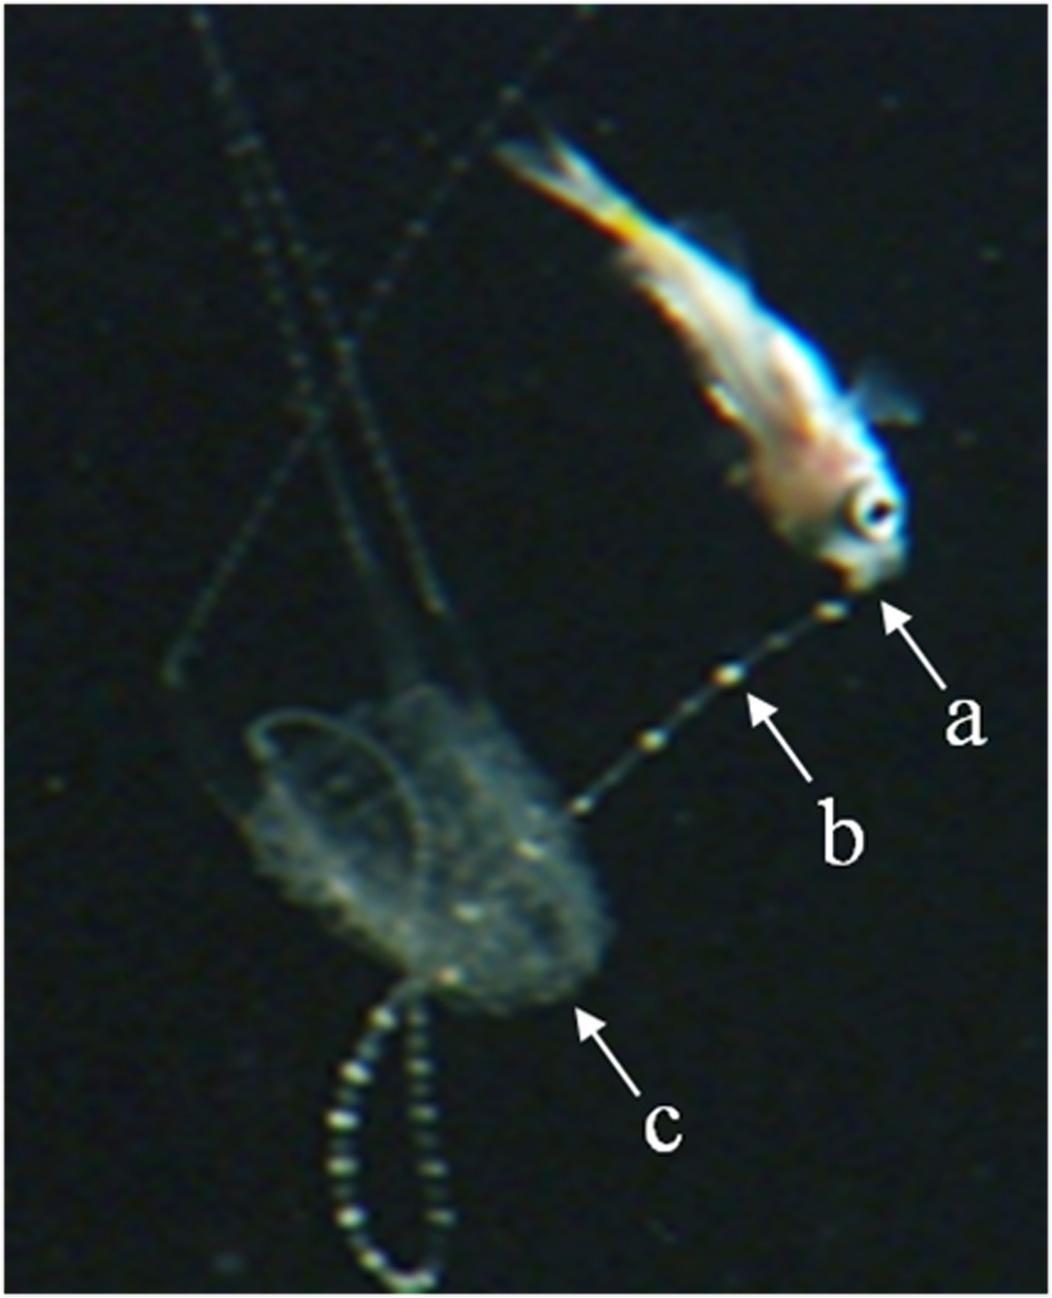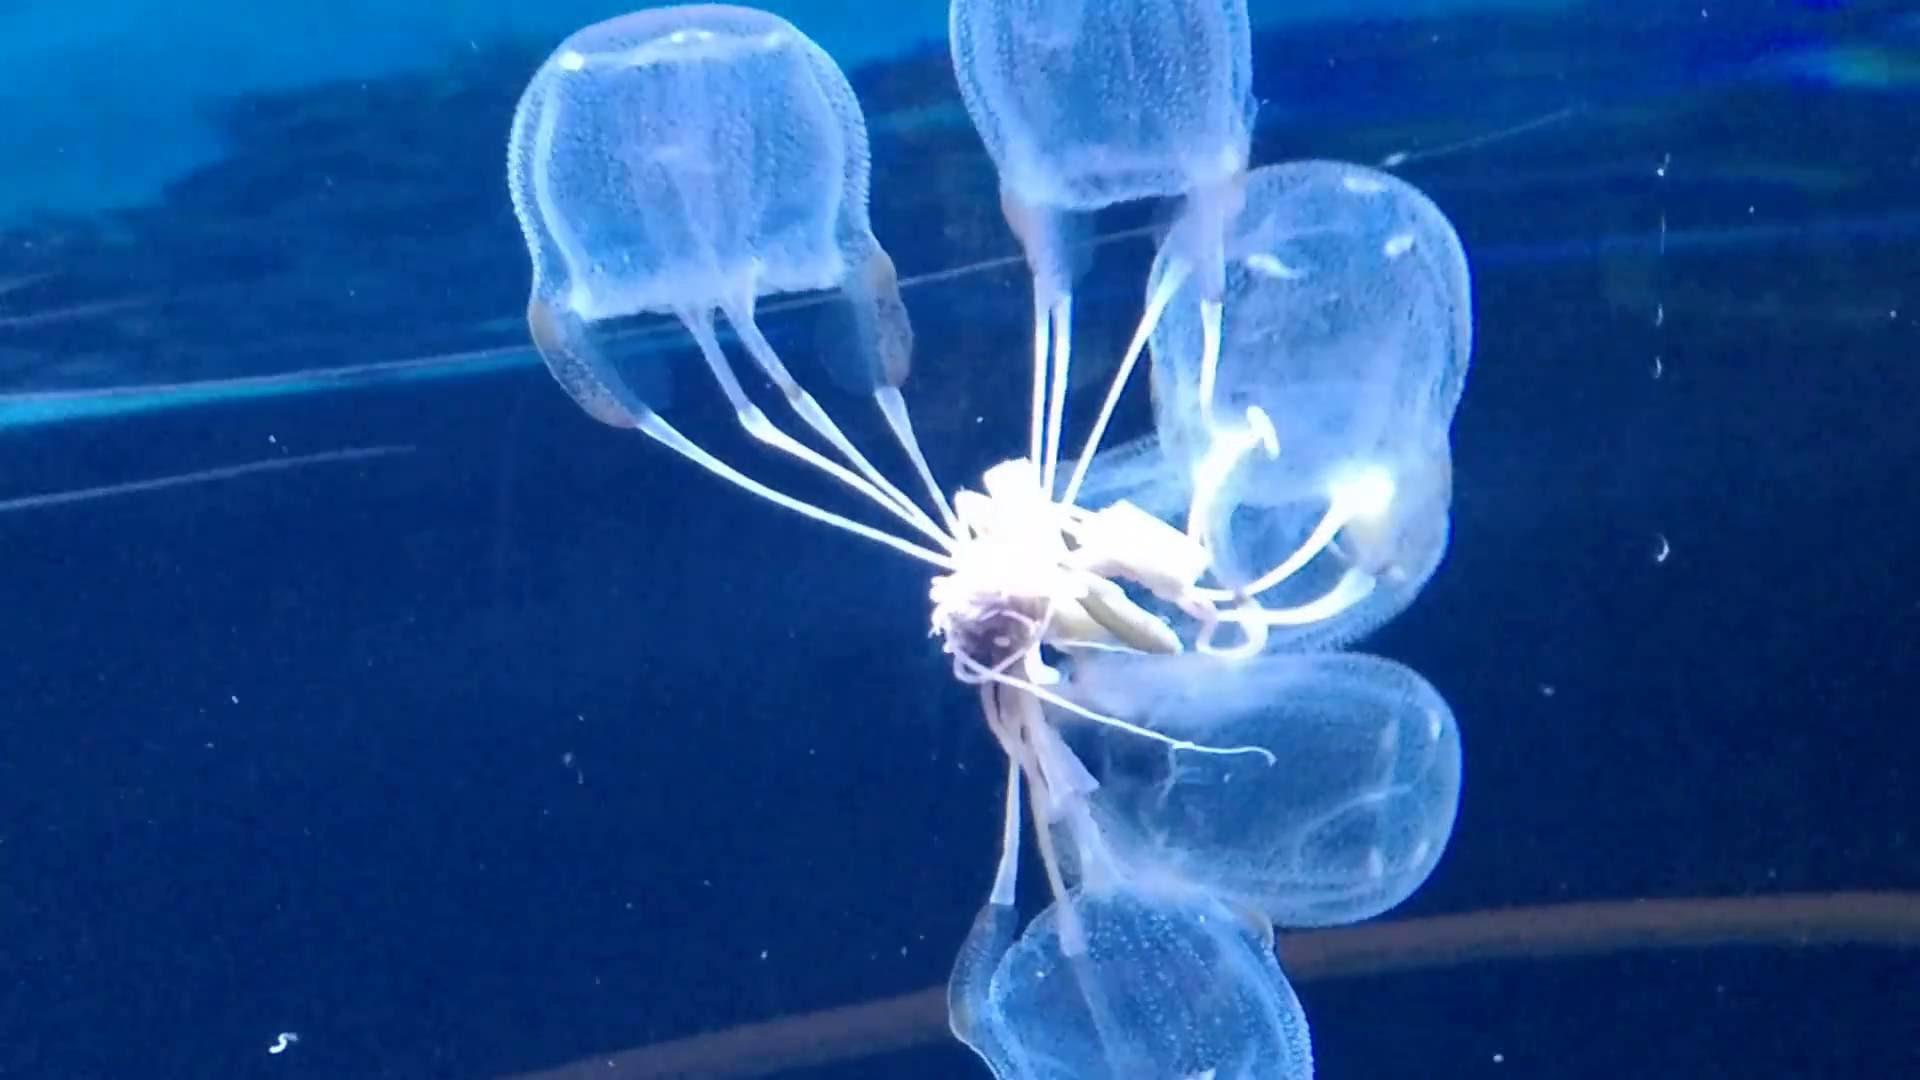The first image is the image on the left, the second image is the image on the right. For the images shown, is this caption "One of the images shows a single fish being pulled in on the tentacles of a lone jellyfish" true? Answer yes or no. Yes. The first image is the image on the left, the second image is the image on the right. For the images displayed, is the sentence "There is at least one moving jellyfish with a rounded crown lit up blue due to the blue background." factually correct? Answer yes or no. Yes. 